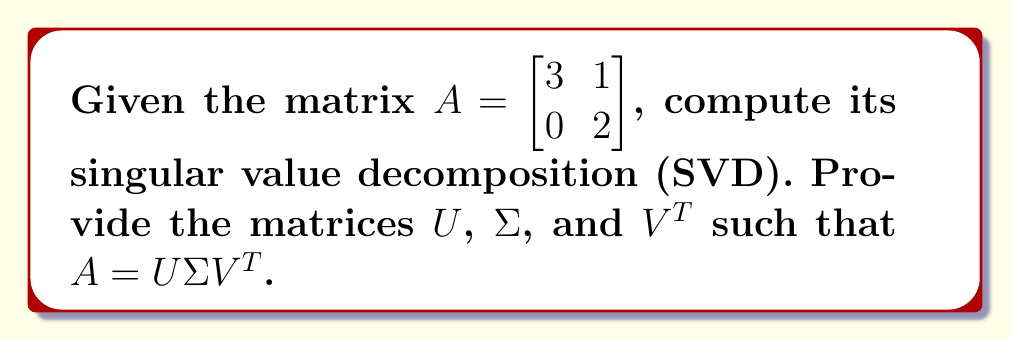Could you help me with this problem? Let's approach this step-by-step:

1) First, we need to calculate $A^TA$ and $AA^T$:

   $A^TA = \begin{bmatrix} 3 & 0 \\ 1 & 2 \end{bmatrix} \begin{bmatrix} 3 & 1 \\ 0 & 2 \end{bmatrix} = \begin{bmatrix} 9 & 3 \\ 3 & 5 \end{bmatrix}$

   $AA^T = \begin{bmatrix} 3 & 1 \\ 0 & 2 \end{bmatrix} \begin{bmatrix} 3 & 0 \\ 1 & 2 \end{bmatrix} = \begin{bmatrix} 10 & 2 \\ 2 & 4 \end{bmatrix}$

2) Now, we find the eigenvalues of $A^TA$ (which are the same as the squares of the singular values):

   $\det(A^TA - \lambda I) = \begin{vmatrix} 9-\lambda & 3 \\ 3 & 5-\lambda \end{vmatrix} = (9-\lambda)(5-\lambda) - 9 = \lambda^2 - 14\lambda + 36 = 0$

   Solving this quadratic equation: $\lambda_1 = 9 + \sqrt{5}$, $\lambda_2 = 9 - \sqrt{5}$

3) The singular values are the square roots of these eigenvalues:

   $\sigma_1 = \sqrt{9 + \sqrt{5}}$, $\sigma_2 = \sqrt{9 - \sqrt{5}}$

4) Now we find the right singular vectors (eigenvectors of $A^TA$):

   For $\lambda_1 = 9 + \sqrt{5}$:
   $\begin{bmatrix} -\sqrt{5} & 3 \\ 3 & -4-\sqrt{5} \end{bmatrix} \begin{bmatrix} x \\ y \end{bmatrix} = \begin{bmatrix} 0 \\ 0 \end{bmatrix}$

   Solving this, we get $v_1 = \frac{1}{\sqrt{10+2\sqrt{5}}} \begin{bmatrix} 3 \\ \sqrt{5}+1 \end{bmatrix}$

   Similarly, for $\lambda_2 = 9 - \sqrt{5}$, we get $v_2 = \frac{1}{\sqrt{10-2\sqrt{5}}} \begin{bmatrix} -(\sqrt{5}+1) \\ 3 \end{bmatrix}$

5) The left singular vectors are:

   $u_1 = \frac{1}{\sigma_1}Av_1 = \frac{1}{\sqrt{10+2\sqrt{5}}} \begin{bmatrix} \sqrt{10+2\sqrt{5}} \\ 2 \end{bmatrix}$

   $u_2 = \frac{1}{\sigma_2}Av_2 = \frac{1}{\sqrt{10-2\sqrt{5}}} \begin{bmatrix} -2 \\ \sqrt{10-2\sqrt{5}} \end{bmatrix}$

6) Therefore, we have:

   $U = \begin{bmatrix} \frac{\sqrt{10+2\sqrt{5}}}{\sqrt{10+2\sqrt{5}}} & \frac{-2}{\sqrt{10-2\sqrt{5}}} \\
   \frac{2}{\sqrt{10+2\sqrt{5}}} & \frac{\sqrt{10-2\sqrt{5}}}{\sqrt{10-2\sqrt{5}}} \end{bmatrix}$

   $\Sigma = \begin{bmatrix} \sqrt{9 + \sqrt{5}} & 0 \\ 0 & \sqrt{9 - \sqrt{5}} \end{bmatrix}$

   $V^T = \begin{bmatrix} \frac{3}{\sqrt{10+2\sqrt{5}}} & \frac{-(\sqrt{5}+1)}{\sqrt{10-2\sqrt{5}}} \\
   \frac{\sqrt{5}+1}{\sqrt{10+2\sqrt{5}}} & \frac{3}{\sqrt{10-2\sqrt{5}}} \end{bmatrix}$
Answer: $U = \begin{bmatrix} \frac{\sqrt{10+2\sqrt{5}}}{\sqrt{10+2\sqrt{5}}} & \frac{-2}{\sqrt{10-2\sqrt{5}}} \\
\frac{2}{\sqrt{10+2\sqrt{5}}} & \frac{\sqrt{10-2\sqrt{5}}}{\sqrt{10-2\sqrt{5}}} \end{bmatrix}$, 
$\Sigma = \begin{bmatrix} \sqrt{9 + \sqrt{5}} & 0 \\ 0 & \sqrt{9 - \sqrt{5}} \end{bmatrix}$, 
$V^T = \begin{bmatrix} \frac{3}{\sqrt{10+2\sqrt{5}}} & \frac{-(\sqrt{5}+1)}{\sqrt{10-2\sqrt{5}}} \\
\frac{\sqrt{5}+1}{\sqrt{10+2\sqrt{5}}} & \frac{3}{\sqrt{10-2\sqrt{5}}} \end{bmatrix}$ 